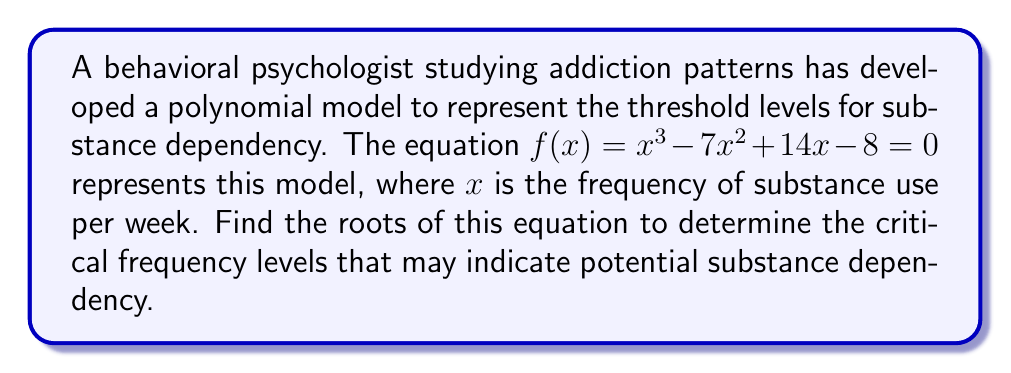Can you answer this question? To find the roots of the equation $f(x) = x^3 - 7x^2 + 14x - 8 = 0$, we need to factor the polynomial. Let's approach this step-by-step:

1) First, let's check if there's a rational root using the rational root theorem. The possible rational roots are the factors of the constant term (8): ±1, ±2, ±4, ±8.

2) Testing these values, we find that $f(1) = 0$. So, $(x-1)$ is a factor.

3) We can use polynomial long division to divide $x^3 - 7x^2 + 14x - 8$ by $(x-1)$:

   $$x^3 - 7x^2 + 14x - 8 = (x-1)(x^2 - 6x + 8)$$

4) Now we need to factor the quadratic $x^2 - 6x + 8$. We can do this by finding two numbers that multiply to give 8 and add to give -6. These numbers are -2 and -4.

5) So, $x^2 - 6x + 8 = (x-2)(x-4)$

6) Putting it all together, we have:

   $$x^3 - 7x^2 + 14x - 8 = (x-1)(x-2)(x-4)$$

7) The roots of the equation are the values that make each factor equal to zero. So, the roots are $x = 1$, $x = 2$, and $x = 4$.
Answer: The roots of the equation are 1, 2, and 4. These represent the critical frequency levels (in times per week) that may indicate potential substance dependency according to the model. 